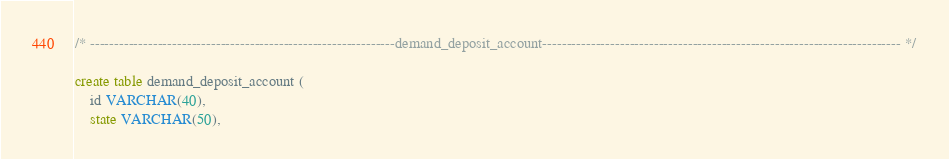<code> <loc_0><loc_0><loc_500><loc_500><_SQL_>/* ---------------------------------------------------------------demand_deposit_account-------------------------------------------------------------------------- */

create table demand_deposit_account (
	id VARCHAR(40),
	state VARCHAR(50),</code> 